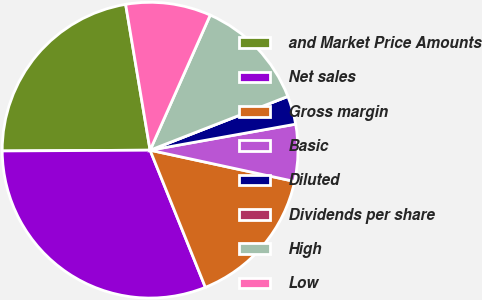Convert chart to OTSL. <chart><loc_0><loc_0><loc_500><loc_500><pie_chart><fcel>and Market Price Amounts<fcel>Net sales<fcel>Gross margin<fcel>Basic<fcel>Diluted<fcel>Dividends per share<fcel>High<fcel>Low<nl><fcel>22.44%<fcel>31.02%<fcel>15.51%<fcel>6.21%<fcel>3.11%<fcel>0.0%<fcel>12.41%<fcel>9.31%<nl></chart> 